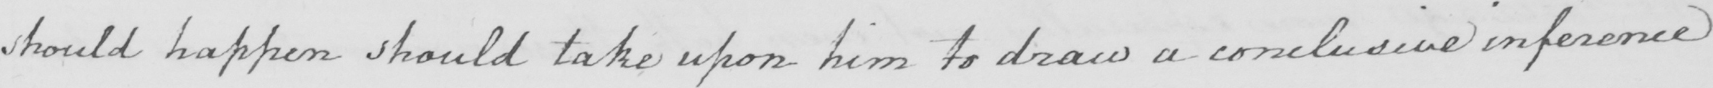What is written in this line of handwriting? should happen should take upon him to draw a conclusive inference 